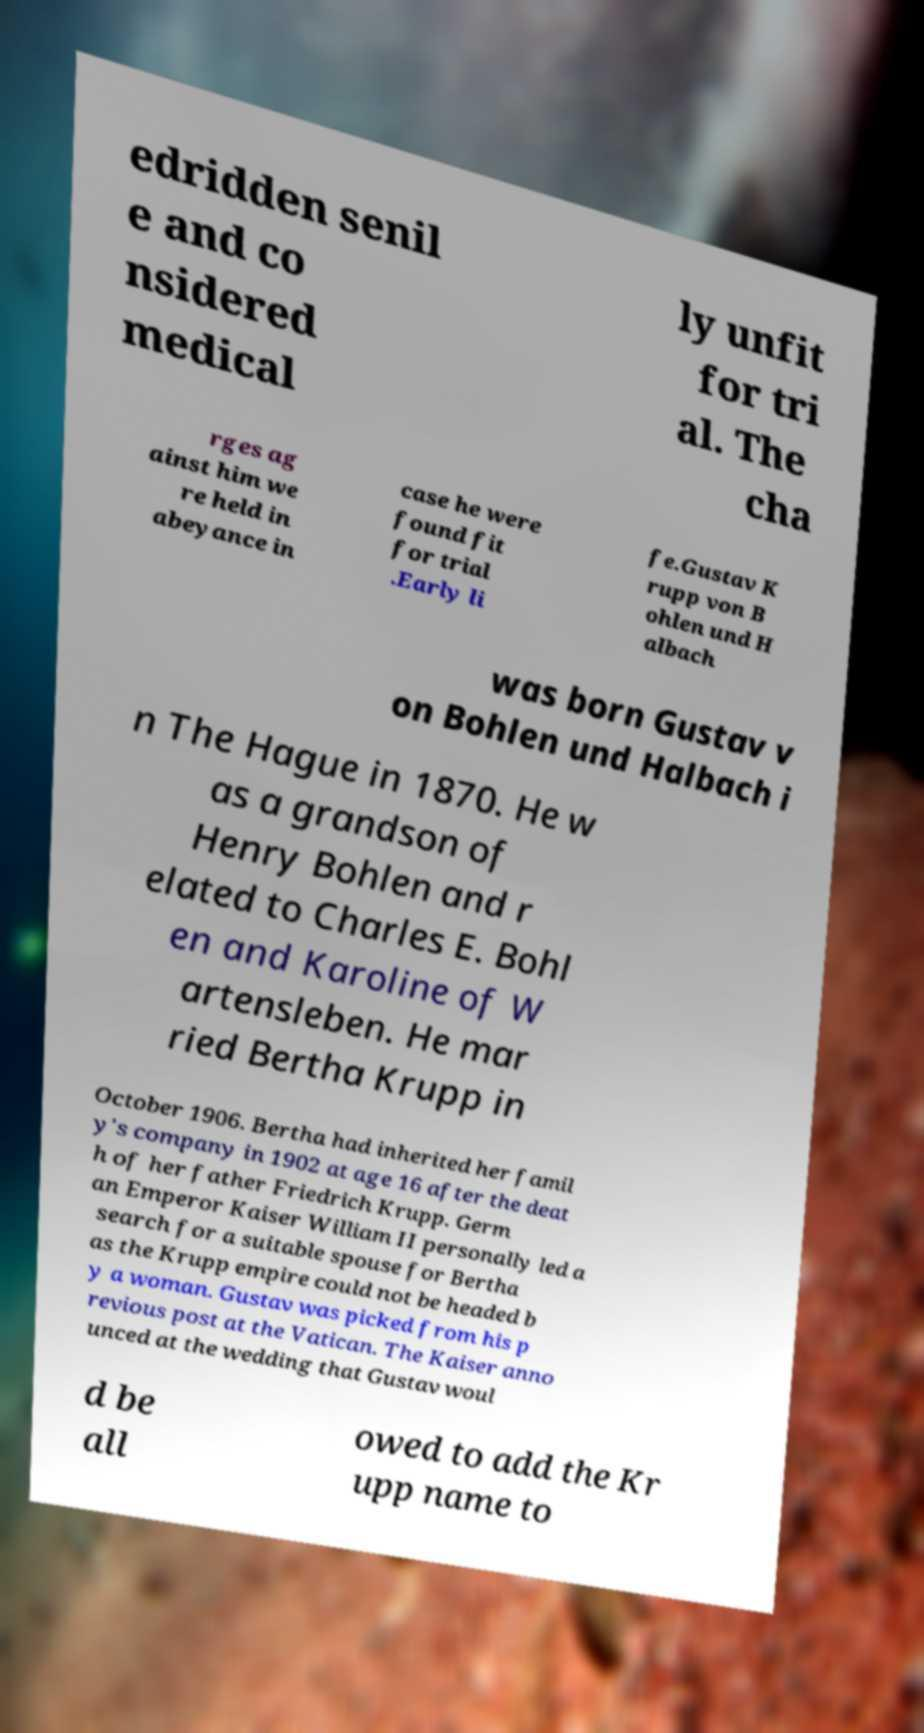Can you accurately transcribe the text from the provided image for me? edridden senil e and co nsidered medical ly unfit for tri al. The cha rges ag ainst him we re held in abeyance in case he were found fit for trial .Early li fe.Gustav K rupp von B ohlen und H albach was born Gustav v on Bohlen und Halbach i n The Hague in 1870. He w as a grandson of Henry Bohlen and r elated to Charles E. Bohl en and Karoline of W artensleben. He mar ried Bertha Krupp in October 1906. Bertha had inherited her famil y's company in 1902 at age 16 after the deat h of her father Friedrich Krupp. Germ an Emperor Kaiser William II personally led a search for a suitable spouse for Bertha as the Krupp empire could not be headed b y a woman. Gustav was picked from his p revious post at the Vatican. The Kaiser anno unced at the wedding that Gustav woul d be all owed to add the Kr upp name to 